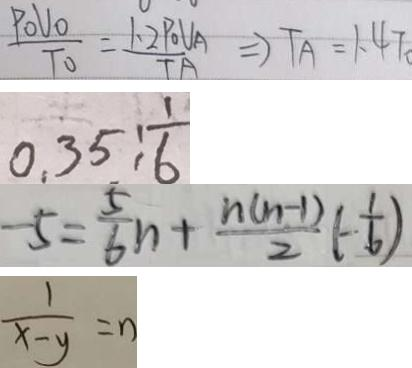<formula> <loc_0><loc_0><loc_500><loc_500>\frac { P o U o } { T o } = \frac { 1 . 2 P o U A } { T A } = ) T A = 1 . 4 7 
 0 . 3 5 : \frac { 1 } { 6 } 
 - 5 = \frac { 5 } { 6 } n + \frac { n ( n - 1 ) } { 2 } ( - \frac { 1 } { 6 } ) 
 \frac { 1 } { x - y } = n</formula> 